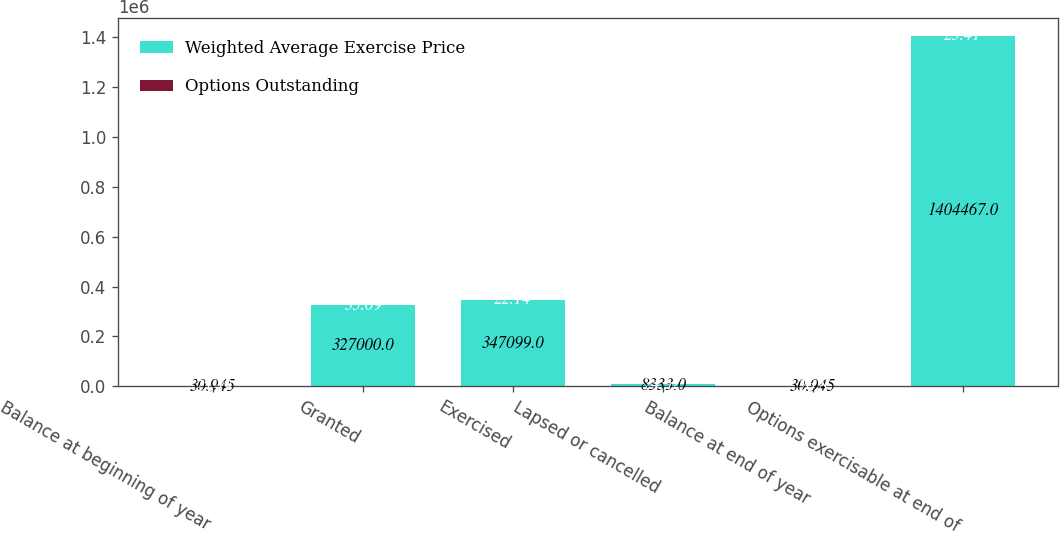<chart> <loc_0><loc_0><loc_500><loc_500><stacked_bar_chart><ecel><fcel>Balance at beginning of year<fcel>Granted<fcel>Exercised<fcel>Lapsed or cancelled<fcel>Balance at end of year<fcel>Options exercisable at end of<nl><fcel>Weighted Average Exercise Price<fcel>30.945<fcel>327000<fcel>347099<fcel>8333<fcel>30.945<fcel>1.40447e+06<nl><fcel>Options Outstanding<fcel>25.49<fcel>35.09<fcel>22.14<fcel>24.52<fcel>26.8<fcel>23.41<nl></chart> 